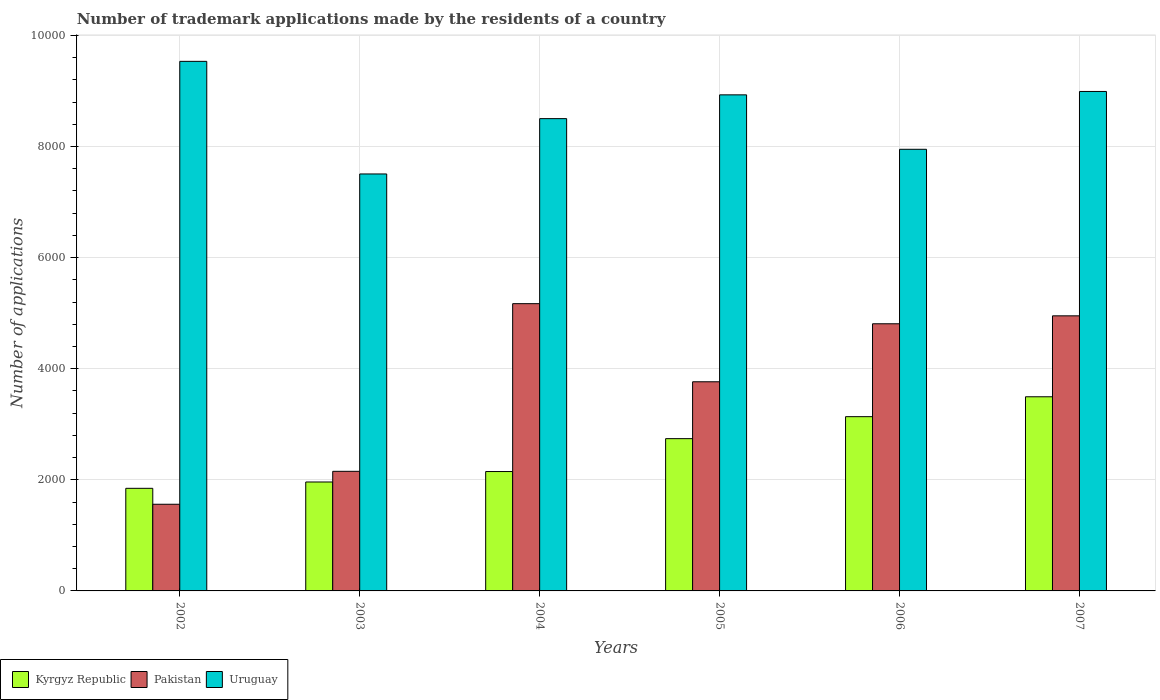How many different coloured bars are there?
Your answer should be compact. 3. Are the number of bars per tick equal to the number of legend labels?
Make the answer very short. Yes. How many bars are there on the 4th tick from the left?
Keep it short and to the point. 3. How many bars are there on the 2nd tick from the right?
Ensure brevity in your answer.  3. What is the label of the 4th group of bars from the left?
Keep it short and to the point. 2005. What is the number of trademark applications made by the residents in Pakistan in 2002?
Your response must be concise. 1560. Across all years, what is the maximum number of trademark applications made by the residents in Kyrgyz Republic?
Provide a succinct answer. 3495. Across all years, what is the minimum number of trademark applications made by the residents in Kyrgyz Republic?
Give a very brief answer. 1847. In which year was the number of trademark applications made by the residents in Pakistan minimum?
Give a very brief answer. 2002. What is the total number of trademark applications made by the residents in Kyrgyz Republic in the graph?
Your answer should be compact. 1.53e+04. What is the difference between the number of trademark applications made by the residents in Uruguay in 2002 and that in 2004?
Keep it short and to the point. 1031. What is the difference between the number of trademark applications made by the residents in Pakistan in 2005 and the number of trademark applications made by the residents in Kyrgyz Republic in 2004?
Offer a very short reply. 1616. What is the average number of trademark applications made by the residents in Uruguay per year?
Give a very brief answer. 8568.67. In the year 2002, what is the difference between the number of trademark applications made by the residents in Uruguay and number of trademark applications made by the residents in Kyrgyz Republic?
Your answer should be very brief. 7686. What is the ratio of the number of trademark applications made by the residents in Uruguay in 2004 to that in 2006?
Make the answer very short. 1.07. Is the number of trademark applications made by the residents in Pakistan in 2002 less than that in 2005?
Make the answer very short. Yes. Is the difference between the number of trademark applications made by the residents in Uruguay in 2006 and 2007 greater than the difference between the number of trademark applications made by the residents in Kyrgyz Republic in 2006 and 2007?
Provide a short and direct response. No. What is the difference between the highest and the second highest number of trademark applications made by the residents in Uruguay?
Give a very brief answer. 542. What is the difference between the highest and the lowest number of trademark applications made by the residents in Uruguay?
Ensure brevity in your answer.  2027. Is the sum of the number of trademark applications made by the residents in Uruguay in 2003 and 2005 greater than the maximum number of trademark applications made by the residents in Pakistan across all years?
Make the answer very short. Yes. What does the 2nd bar from the left in 2004 represents?
Make the answer very short. Pakistan. What does the 3rd bar from the right in 2005 represents?
Your answer should be very brief. Kyrgyz Republic. Are all the bars in the graph horizontal?
Keep it short and to the point. No. How many years are there in the graph?
Your answer should be very brief. 6. What is the difference between two consecutive major ticks on the Y-axis?
Your response must be concise. 2000. Are the values on the major ticks of Y-axis written in scientific E-notation?
Offer a terse response. No. Does the graph contain any zero values?
Ensure brevity in your answer.  No. Where does the legend appear in the graph?
Provide a short and direct response. Bottom left. What is the title of the graph?
Your answer should be very brief. Number of trademark applications made by the residents of a country. Does "Malawi" appear as one of the legend labels in the graph?
Your answer should be compact. No. What is the label or title of the Y-axis?
Offer a very short reply. Number of applications. What is the Number of applications in Kyrgyz Republic in 2002?
Keep it short and to the point. 1847. What is the Number of applications in Pakistan in 2002?
Give a very brief answer. 1560. What is the Number of applications of Uruguay in 2002?
Your answer should be compact. 9533. What is the Number of applications in Kyrgyz Republic in 2003?
Make the answer very short. 1961. What is the Number of applications in Pakistan in 2003?
Offer a very short reply. 2153. What is the Number of applications of Uruguay in 2003?
Provide a succinct answer. 7506. What is the Number of applications of Kyrgyz Republic in 2004?
Ensure brevity in your answer.  2149. What is the Number of applications in Pakistan in 2004?
Your answer should be very brief. 5171. What is the Number of applications of Uruguay in 2004?
Offer a terse response. 8502. What is the Number of applications in Kyrgyz Republic in 2005?
Offer a terse response. 2741. What is the Number of applications of Pakistan in 2005?
Your answer should be very brief. 3765. What is the Number of applications of Uruguay in 2005?
Your answer should be compact. 8930. What is the Number of applications of Kyrgyz Republic in 2006?
Offer a terse response. 3137. What is the Number of applications in Pakistan in 2006?
Offer a very short reply. 4809. What is the Number of applications in Uruguay in 2006?
Your answer should be very brief. 7950. What is the Number of applications in Kyrgyz Republic in 2007?
Provide a short and direct response. 3495. What is the Number of applications in Pakistan in 2007?
Ensure brevity in your answer.  4952. What is the Number of applications of Uruguay in 2007?
Your answer should be very brief. 8991. Across all years, what is the maximum Number of applications of Kyrgyz Republic?
Make the answer very short. 3495. Across all years, what is the maximum Number of applications in Pakistan?
Make the answer very short. 5171. Across all years, what is the maximum Number of applications of Uruguay?
Give a very brief answer. 9533. Across all years, what is the minimum Number of applications in Kyrgyz Republic?
Provide a short and direct response. 1847. Across all years, what is the minimum Number of applications in Pakistan?
Provide a short and direct response. 1560. Across all years, what is the minimum Number of applications of Uruguay?
Your response must be concise. 7506. What is the total Number of applications in Kyrgyz Republic in the graph?
Offer a terse response. 1.53e+04. What is the total Number of applications of Pakistan in the graph?
Your answer should be compact. 2.24e+04. What is the total Number of applications of Uruguay in the graph?
Give a very brief answer. 5.14e+04. What is the difference between the Number of applications of Kyrgyz Republic in 2002 and that in 2003?
Offer a very short reply. -114. What is the difference between the Number of applications of Pakistan in 2002 and that in 2003?
Ensure brevity in your answer.  -593. What is the difference between the Number of applications in Uruguay in 2002 and that in 2003?
Your answer should be compact. 2027. What is the difference between the Number of applications in Kyrgyz Republic in 2002 and that in 2004?
Ensure brevity in your answer.  -302. What is the difference between the Number of applications of Pakistan in 2002 and that in 2004?
Make the answer very short. -3611. What is the difference between the Number of applications in Uruguay in 2002 and that in 2004?
Provide a succinct answer. 1031. What is the difference between the Number of applications in Kyrgyz Republic in 2002 and that in 2005?
Provide a short and direct response. -894. What is the difference between the Number of applications in Pakistan in 2002 and that in 2005?
Provide a short and direct response. -2205. What is the difference between the Number of applications of Uruguay in 2002 and that in 2005?
Give a very brief answer. 603. What is the difference between the Number of applications of Kyrgyz Republic in 2002 and that in 2006?
Provide a short and direct response. -1290. What is the difference between the Number of applications of Pakistan in 2002 and that in 2006?
Make the answer very short. -3249. What is the difference between the Number of applications of Uruguay in 2002 and that in 2006?
Provide a short and direct response. 1583. What is the difference between the Number of applications in Kyrgyz Republic in 2002 and that in 2007?
Your answer should be compact. -1648. What is the difference between the Number of applications of Pakistan in 2002 and that in 2007?
Ensure brevity in your answer.  -3392. What is the difference between the Number of applications in Uruguay in 2002 and that in 2007?
Offer a very short reply. 542. What is the difference between the Number of applications in Kyrgyz Republic in 2003 and that in 2004?
Provide a short and direct response. -188. What is the difference between the Number of applications in Pakistan in 2003 and that in 2004?
Provide a short and direct response. -3018. What is the difference between the Number of applications in Uruguay in 2003 and that in 2004?
Offer a very short reply. -996. What is the difference between the Number of applications in Kyrgyz Republic in 2003 and that in 2005?
Your answer should be compact. -780. What is the difference between the Number of applications in Pakistan in 2003 and that in 2005?
Make the answer very short. -1612. What is the difference between the Number of applications of Uruguay in 2003 and that in 2005?
Ensure brevity in your answer.  -1424. What is the difference between the Number of applications of Kyrgyz Republic in 2003 and that in 2006?
Make the answer very short. -1176. What is the difference between the Number of applications in Pakistan in 2003 and that in 2006?
Your response must be concise. -2656. What is the difference between the Number of applications of Uruguay in 2003 and that in 2006?
Ensure brevity in your answer.  -444. What is the difference between the Number of applications of Kyrgyz Republic in 2003 and that in 2007?
Keep it short and to the point. -1534. What is the difference between the Number of applications in Pakistan in 2003 and that in 2007?
Ensure brevity in your answer.  -2799. What is the difference between the Number of applications in Uruguay in 2003 and that in 2007?
Ensure brevity in your answer.  -1485. What is the difference between the Number of applications of Kyrgyz Republic in 2004 and that in 2005?
Offer a terse response. -592. What is the difference between the Number of applications of Pakistan in 2004 and that in 2005?
Give a very brief answer. 1406. What is the difference between the Number of applications in Uruguay in 2004 and that in 2005?
Provide a short and direct response. -428. What is the difference between the Number of applications in Kyrgyz Republic in 2004 and that in 2006?
Make the answer very short. -988. What is the difference between the Number of applications in Pakistan in 2004 and that in 2006?
Provide a short and direct response. 362. What is the difference between the Number of applications in Uruguay in 2004 and that in 2006?
Your answer should be very brief. 552. What is the difference between the Number of applications of Kyrgyz Republic in 2004 and that in 2007?
Provide a succinct answer. -1346. What is the difference between the Number of applications in Pakistan in 2004 and that in 2007?
Your answer should be very brief. 219. What is the difference between the Number of applications in Uruguay in 2004 and that in 2007?
Give a very brief answer. -489. What is the difference between the Number of applications in Kyrgyz Republic in 2005 and that in 2006?
Make the answer very short. -396. What is the difference between the Number of applications of Pakistan in 2005 and that in 2006?
Your answer should be very brief. -1044. What is the difference between the Number of applications in Uruguay in 2005 and that in 2006?
Make the answer very short. 980. What is the difference between the Number of applications in Kyrgyz Republic in 2005 and that in 2007?
Your response must be concise. -754. What is the difference between the Number of applications of Pakistan in 2005 and that in 2007?
Offer a very short reply. -1187. What is the difference between the Number of applications in Uruguay in 2005 and that in 2007?
Make the answer very short. -61. What is the difference between the Number of applications of Kyrgyz Republic in 2006 and that in 2007?
Keep it short and to the point. -358. What is the difference between the Number of applications in Pakistan in 2006 and that in 2007?
Offer a very short reply. -143. What is the difference between the Number of applications of Uruguay in 2006 and that in 2007?
Give a very brief answer. -1041. What is the difference between the Number of applications of Kyrgyz Republic in 2002 and the Number of applications of Pakistan in 2003?
Give a very brief answer. -306. What is the difference between the Number of applications of Kyrgyz Republic in 2002 and the Number of applications of Uruguay in 2003?
Ensure brevity in your answer.  -5659. What is the difference between the Number of applications of Pakistan in 2002 and the Number of applications of Uruguay in 2003?
Provide a short and direct response. -5946. What is the difference between the Number of applications in Kyrgyz Republic in 2002 and the Number of applications in Pakistan in 2004?
Your answer should be very brief. -3324. What is the difference between the Number of applications of Kyrgyz Republic in 2002 and the Number of applications of Uruguay in 2004?
Your answer should be compact. -6655. What is the difference between the Number of applications in Pakistan in 2002 and the Number of applications in Uruguay in 2004?
Give a very brief answer. -6942. What is the difference between the Number of applications of Kyrgyz Republic in 2002 and the Number of applications of Pakistan in 2005?
Offer a very short reply. -1918. What is the difference between the Number of applications of Kyrgyz Republic in 2002 and the Number of applications of Uruguay in 2005?
Give a very brief answer. -7083. What is the difference between the Number of applications in Pakistan in 2002 and the Number of applications in Uruguay in 2005?
Your response must be concise. -7370. What is the difference between the Number of applications in Kyrgyz Republic in 2002 and the Number of applications in Pakistan in 2006?
Ensure brevity in your answer.  -2962. What is the difference between the Number of applications of Kyrgyz Republic in 2002 and the Number of applications of Uruguay in 2006?
Your response must be concise. -6103. What is the difference between the Number of applications of Pakistan in 2002 and the Number of applications of Uruguay in 2006?
Your response must be concise. -6390. What is the difference between the Number of applications of Kyrgyz Republic in 2002 and the Number of applications of Pakistan in 2007?
Your answer should be very brief. -3105. What is the difference between the Number of applications in Kyrgyz Republic in 2002 and the Number of applications in Uruguay in 2007?
Ensure brevity in your answer.  -7144. What is the difference between the Number of applications of Pakistan in 2002 and the Number of applications of Uruguay in 2007?
Keep it short and to the point. -7431. What is the difference between the Number of applications in Kyrgyz Republic in 2003 and the Number of applications in Pakistan in 2004?
Provide a succinct answer. -3210. What is the difference between the Number of applications of Kyrgyz Republic in 2003 and the Number of applications of Uruguay in 2004?
Your response must be concise. -6541. What is the difference between the Number of applications of Pakistan in 2003 and the Number of applications of Uruguay in 2004?
Your answer should be very brief. -6349. What is the difference between the Number of applications of Kyrgyz Republic in 2003 and the Number of applications of Pakistan in 2005?
Offer a terse response. -1804. What is the difference between the Number of applications of Kyrgyz Republic in 2003 and the Number of applications of Uruguay in 2005?
Offer a very short reply. -6969. What is the difference between the Number of applications in Pakistan in 2003 and the Number of applications in Uruguay in 2005?
Offer a terse response. -6777. What is the difference between the Number of applications in Kyrgyz Republic in 2003 and the Number of applications in Pakistan in 2006?
Your answer should be very brief. -2848. What is the difference between the Number of applications in Kyrgyz Republic in 2003 and the Number of applications in Uruguay in 2006?
Provide a succinct answer. -5989. What is the difference between the Number of applications of Pakistan in 2003 and the Number of applications of Uruguay in 2006?
Your response must be concise. -5797. What is the difference between the Number of applications in Kyrgyz Republic in 2003 and the Number of applications in Pakistan in 2007?
Keep it short and to the point. -2991. What is the difference between the Number of applications of Kyrgyz Republic in 2003 and the Number of applications of Uruguay in 2007?
Keep it short and to the point. -7030. What is the difference between the Number of applications of Pakistan in 2003 and the Number of applications of Uruguay in 2007?
Provide a succinct answer. -6838. What is the difference between the Number of applications in Kyrgyz Republic in 2004 and the Number of applications in Pakistan in 2005?
Provide a short and direct response. -1616. What is the difference between the Number of applications in Kyrgyz Republic in 2004 and the Number of applications in Uruguay in 2005?
Offer a terse response. -6781. What is the difference between the Number of applications in Pakistan in 2004 and the Number of applications in Uruguay in 2005?
Make the answer very short. -3759. What is the difference between the Number of applications of Kyrgyz Republic in 2004 and the Number of applications of Pakistan in 2006?
Make the answer very short. -2660. What is the difference between the Number of applications of Kyrgyz Republic in 2004 and the Number of applications of Uruguay in 2006?
Your answer should be compact. -5801. What is the difference between the Number of applications of Pakistan in 2004 and the Number of applications of Uruguay in 2006?
Offer a very short reply. -2779. What is the difference between the Number of applications of Kyrgyz Republic in 2004 and the Number of applications of Pakistan in 2007?
Keep it short and to the point. -2803. What is the difference between the Number of applications in Kyrgyz Republic in 2004 and the Number of applications in Uruguay in 2007?
Give a very brief answer. -6842. What is the difference between the Number of applications in Pakistan in 2004 and the Number of applications in Uruguay in 2007?
Offer a terse response. -3820. What is the difference between the Number of applications in Kyrgyz Republic in 2005 and the Number of applications in Pakistan in 2006?
Offer a terse response. -2068. What is the difference between the Number of applications in Kyrgyz Republic in 2005 and the Number of applications in Uruguay in 2006?
Provide a succinct answer. -5209. What is the difference between the Number of applications in Pakistan in 2005 and the Number of applications in Uruguay in 2006?
Give a very brief answer. -4185. What is the difference between the Number of applications in Kyrgyz Republic in 2005 and the Number of applications in Pakistan in 2007?
Keep it short and to the point. -2211. What is the difference between the Number of applications of Kyrgyz Republic in 2005 and the Number of applications of Uruguay in 2007?
Offer a terse response. -6250. What is the difference between the Number of applications of Pakistan in 2005 and the Number of applications of Uruguay in 2007?
Give a very brief answer. -5226. What is the difference between the Number of applications of Kyrgyz Republic in 2006 and the Number of applications of Pakistan in 2007?
Provide a succinct answer. -1815. What is the difference between the Number of applications of Kyrgyz Republic in 2006 and the Number of applications of Uruguay in 2007?
Ensure brevity in your answer.  -5854. What is the difference between the Number of applications in Pakistan in 2006 and the Number of applications in Uruguay in 2007?
Offer a terse response. -4182. What is the average Number of applications of Kyrgyz Republic per year?
Make the answer very short. 2555. What is the average Number of applications in Pakistan per year?
Provide a succinct answer. 3735. What is the average Number of applications of Uruguay per year?
Keep it short and to the point. 8568.67. In the year 2002, what is the difference between the Number of applications in Kyrgyz Republic and Number of applications in Pakistan?
Give a very brief answer. 287. In the year 2002, what is the difference between the Number of applications in Kyrgyz Republic and Number of applications in Uruguay?
Provide a short and direct response. -7686. In the year 2002, what is the difference between the Number of applications in Pakistan and Number of applications in Uruguay?
Ensure brevity in your answer.  -7973. In the year 2003, what is the difference between the Number of applications in Kyrgyz Republic and Number of applications in Pakistan?
Your answer should be very brief. -192. In the year 2003, what is the difference between the Number of applications of Kyrgyz Republic and Number of applications of Uruguay?
Provide a short and direct response. -5545. In the year 2003, what is the difference between the Number of applications of Pakistan and Number of applications of Uruguay?
Your answer should be very brief. -5353. In the year 2004, what is the difference between the Number of applications of Kyrgyz Republic and Number of applications of Pakistan?
Your response must be concise. -3022. In the year 2004, what is the difference between the Number of applications of Kyrgyz Republic and Number of applications of Uruguay?
Your answer should be very brief. -6353. In the year 2004, what is the difference between the Number of applications of Pakistan and Number of applications of Uruguay?
Give a very brief answer. -3331. In the year 2005, what is the difference between the Number of applications in Kyrgyz Republic and Number of applications in Pakistan?
Your answer should be compact. -1024. In the year 2005, what is the difference between the Number of applications of Kyrgyz Republic and Number of applications of Uruguay?
Your answer should be compact. -6189. In the year 2005, what is the difference between the Number of applications of Pakistan and Number of applications of Uruguay?
Your answer should be very brief. -5165. In the year 2006, what is the difference between the Number of applications of Kyrgyz Republic and Number of applications of Pakistan?
Make the answer very short. -1672. In the year 2006, what is the difference between the Number of applications of Kyrgyz Republic and Number of applications of Uruguay?
Offer a terse response. -4813. In the year 2006, what is the difference between the Number of applications in Pakistan and Number of applications in Uruguay?
Give a very brief answer. -3141. In the year 2007, what is the difference between the Number of applications of Kyrgyz Republic and Number of applications of Pakistan?
Your answer should be compact. -1457. In the year 2007, what is the difference between the Number of applications of Kyrgyz Republic and Number of applications of Uruguay?
Make the answer very short. -5496. In the year 2007, what is the difference between the Number of applications of Pakistan and Number of applications of Uruguay?
Keep it short and to the point. -4039. What is the ratio of the Number of applications of Kyrgyz Republic in 2002 to that in 2003?
Give a very brief answer. 0.94. What is the ratio of the Number of applications in Pakistan in 2002 to that in 2003?
Give a very brief answer. 0.72. What is the ratio of the Number of applications in Uruguay in 2002 to that in 2003?
Your response must be concise. 1.27. What is the ratio of the Number of applications of Kyrgyz Republic in 2002 to that in 2004?
Make the answer very short. 0.86. What is the ratio of the Number of applications of Pakistan in 2002 to that in 2004?
Give a very brief answer. 0.3. What is the ratio of the Number of applications of Uruguay in 2002 to that in 2004?
Your answer should be very brief. 1.12. What is the ratio of the Number of applications of Kyrgyz Republic in 2002 to that in 2005?
Provide a short and direct response. 0.67. What is the ratio of the Number of applications in Pakistan in 2002 to that in 2005?
Your answer should be very brief. 0.41. What is the ratio of the Number of applications of Uruguay in 2002 to that in 2005?
Your response must be concise. 1.07. What is the ratio of the Number of applications in Kyrgyz Republic in 2002 to that in 2006?
Ensure brevity in your answer.  0.59. What is the ratio of the Number of applications in Pakistan in 2002 to that in 2006?
Make the answer very short. 0.32. What is the ratio of the Number of applications in Uruguay in 2002 to that in 2006?
Your answer should be very brief. 1.2. What is the ratio of the Number of applications in Kyrgyz Republic in 2002 to that in 2007?
Make the answer very short. 0.53. What is the ratio of the Number of applications of Pakistan in 2002 to that in 2007?
Provide a short and direct response. 0.32. What is the ratio of the Number of applications of Uruguay in 2002 to that in 2007?
Make the answer very short. 1.06. What is the ratio of the Number of applications in Kyrgyz Republic in 2003 to that in 2004?
Offer a very short reply. 0.91. What is the ratio of the Number of applications of Pakistan in 2003 to that in 2004?
Your answer should be very brief. 0.42. What is the ratio of the Number of applications in Uruguay in 2003 to that in 2004?
Ensure brevity in your answer.  0.88. What is the ratio of the Number of applications in Kyrgyz Republic in 2003 to that in 2005?
Your answer should be very brief. 0.72. What is the ratio of the Number of applications of Pakistan in 2003 to that in 2005?
Offer a terse response. 0.57. What is the ratio of the Number of applications in Uruguay in 2003 to that in 2005?
Ensure brevity in your answer.  0.84. What is the ratio of the Number of applications in Kyrgyz Republic in 2003 to that in 2006?
Ensure brevity in your answer.  0.63. What is the ratio of the Number of applications of Pakistan in 2003 to that in 2006?
Keep it short and to the point. 0.45. What is the ratio of the Number of applications of Uruguay in 2003 to that in 2006?
Keep it short and to the point. 0.94. What is the ratio of the Number of applications in Kyrgyz Republic in 2003 to that in 2007?
Ensure brevity in your answer.  0.56. What is the ratio of the Number of applications in Pakistan in 2003 to that in 2007?
Your answer should be very brief. 0.43. What is the ratio of the Number of applications in Uruguay in 2003 to that in 2007?
Give a very brief answer. 0.83. What is the ratio of the Number of applications of Kyrgyz Republic in 2004 to that in 2005?
Your response must be concise. 0.78. What is the ratio of the Number of applications of Pakistan in 2004 to that in 2005?
Offer a very short reply. 1.37. What is the ratio of the Number of applications in Uruguay in 2004 to that in 2005?
Ensure brevity in your answer.  0.95. What is the ratio of the Number of applications in Kyrgyz Republic in 2004 to that in 2006?
Keep it short and to the point. 0.69. What is the ratio of the Number of applications in Pakistan in 2004 to that in 2006?
Give a very brief answer. 1.08. What is the ratio of the Number of applications in Uruguay in 2004 to that in 2006?
Ensure brevity in your answer.  1.07. What is the ratio of the Number of applications in Kyrgyz Republic in 2004 to that in 2007?
Ensure brevity in your answer.  0.61. What is the ratio of the Number of applications of Pakistan in 2004 to that in 2007?
Make the answer very short. 1.04. What is the ratio of the Number of applications of Uruguay in 2004 to that in 2007?
Ensure brevity in your answer.  0.95. What is the ratio of the Number of applications in Kyrgyz Republic in 2005 to that in 2006?
Provide a short and direct response. 0.87. What is the ratio of the Number of applications in Pakistan in 2005 to that in 2006?
Your answer should be very brief. 0.78. What is the ratio of the Number of applications of Uruguay in 2005 to that in 2006?
Offer a very short reply. 1.12. What is the ratio of the Number of applications in Kyrgyz Republic in 2005 to that in 2007?
Your response must be concise. 0.78. What is the ratio of the Number of applications of Pakistan in 2005 to that in 2007?
Offer a very short reply. 0.76. What is the ratio of the Number of applications of Uruguay in 2005 to that in 2007?
Your answer should be compact. 0.99. What is the ratio of the Number of applications of Kyrgyz Republic in 2006 to that in 2007?
Your response must be concise. 0.9. What is the ratio of the Number of applications of Pakistan in 2006 to that in 2007?
Provide a short and direct response. 0.97. What is the ratio of the Number of applications in Uruguay in 2006 to that in 2007?
Your response must be concise. 0.88. What is the difference between the highest and the second highest Number of applications of Kyrgyz Republic?
Your answer should be very brief. 358. What is the difference between the highest and the second highest Number of applications in Pakistan?
Your response must be concise. 219. What is the difference between the highest and the second highest Number of applications of Uruguay?
Offer a terse response. 542. What is the difference between the highest and the lowest Number of applications in Kyrgyz Republic?
Ensure brevity in your answer.  1648. What is the difference between the highest and the lowest Number of applications of Pakistan?
Give a very brief answer. 3611. What is the difference between the highest and the lowest Number of applications of Uruguay?
Your response must be concise. 2027. 